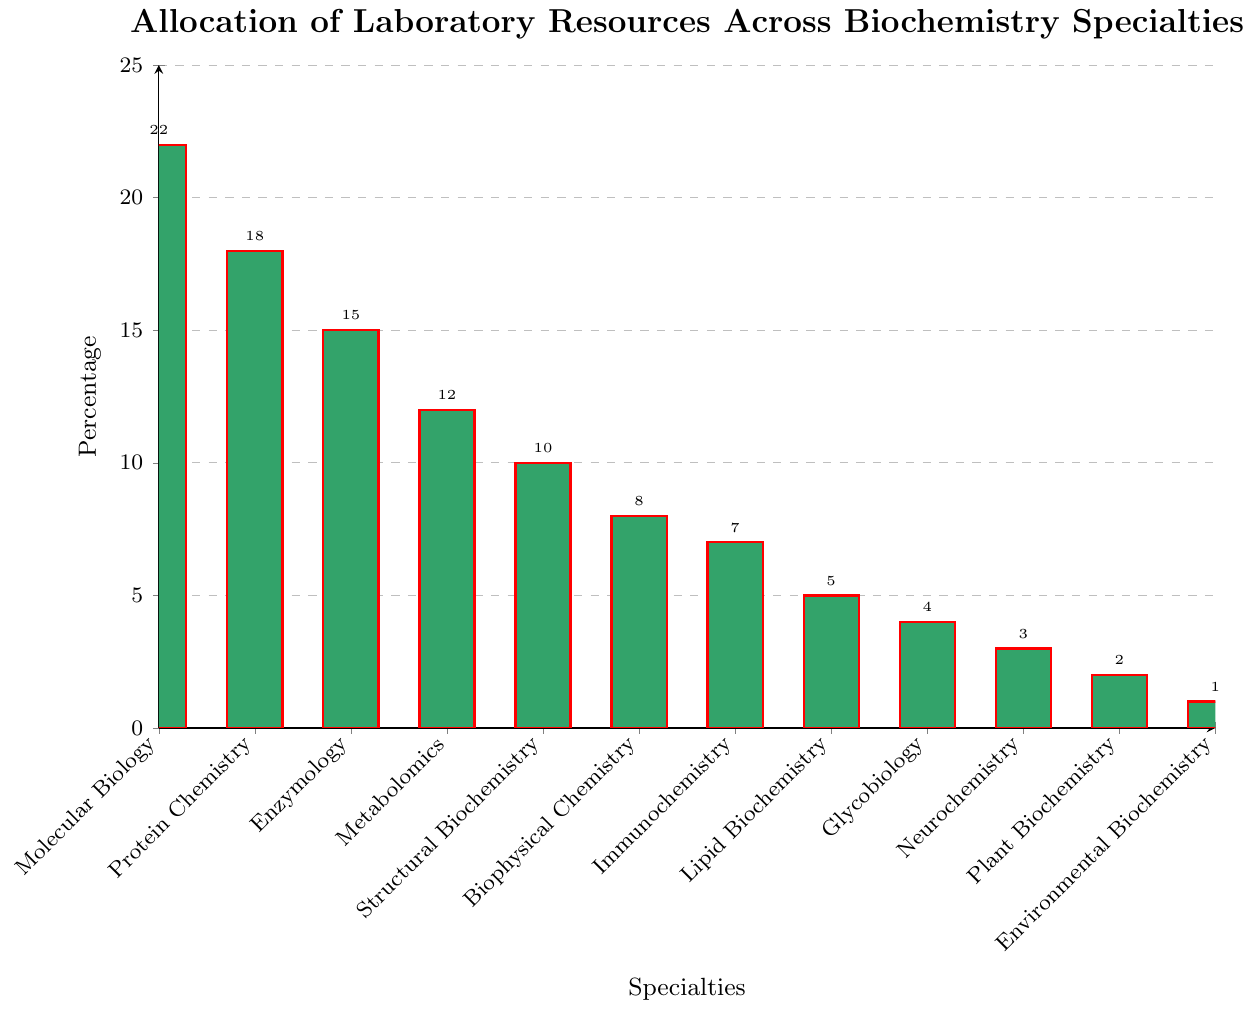Which specialty has the highest allocation of laboratory resources? From the bar chart, the specialty with the tallest bar represents the highest allocation. This is "Molecular Biology" with 22% allocation.
Answer: Molecular Biology Which specialty has the second lowest allocation of laboratory resources? By looking at the lengths of the bars from the smallest to the second smallest, "Plant Biochemistry" is the second lowest with 2% allocation, after "Environmental Biochemistry" which has 1%.
Answer: Plant Biochemistry How much more allocation does Molecular Biology have compared to Environmental Biochemistry? Molecular Biology's allocation is 22%, and Environmental Biochemistry's allocation is 1%. The difference between them is 22 - 1 = 21%.
Answer: 21% What is the combined allocation percentage for the top three specialties? The top three specialties based on allocation percentages are "Molecular Biology" (22%), "Protein Chemistry" (18%), and "Enzymology" (15%). The combined allocation is 22 + 18 + 15 = 55%.
Answer: 55% How many specialties have an allocation of 10% or more? By looking at the bar heights, those with 10% or more are "Molecular Biology", "Protein Chemistry", "Enzymology", "Metabolomics", and "Structural Biochemistry". There are 5 such specialties.
Answer: 5 Which specialty shows an allocation less than the median value of all allocations? The allocations are: 22, 18, 15, 12, 10, 8, 7, 5, 4, 3, 2, 1. The median value (middle value) here is (10+8)/2 = 9%. Specialties with allocations less than 9% are: "Biophysical Chemistry", "Immunochemistry", "Lipid Biochemistry", "Glycobiology", "Neurochemistry", "Plant Biochemistry", "Environmental Biochemistry". There are 7 specialties.
Answer: 7 What percentage of allocation is dedicated to specialties below 5%? Specialties below 5% are "Glycobiology" (4%), "Neurochemistry" (3%), "Plant Biochemistry" (2%), and "Environmental Biochemistry" (1%). The combined allocation is 4 + 3 + 2 + 1 = 10%.
Answer: 10% Which specialty is represented by a green bar with the shortest height? The specialty with the shortest bar height is "Environmental Biochemistry," which has an allocation of 1%.
Answer: Environmental Biochemistry What is the average allocation percentage for all specialties? The sum of all allocations is 22 + 18 + 15 + 12 + 10 + 8 + 7 + 5 + 4 + 3 + 2 + 1 = 107%. There are 12 specialties, thus the average is 107 / 12 ≈ 8.92%.
Answer: 8.92% Is there any specialty with twice the allocation percentage of Biophysical Chemistry? Biophysical Chemistry has an allocation of 8%. Twice this value is 2 * 8 = 16%. Checking the chart, no specialty has exactly 16% allocation; Protein Chemistry is close with 18%.
Answer: No 